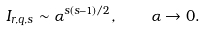<formula> <loc_0><loc_0><loc_500><loc_500>I _ { r , q , s } \sim \alpha ^ { s ( s - 1 ) / 2 } , \quad \alpha \to 0 .</formula> 